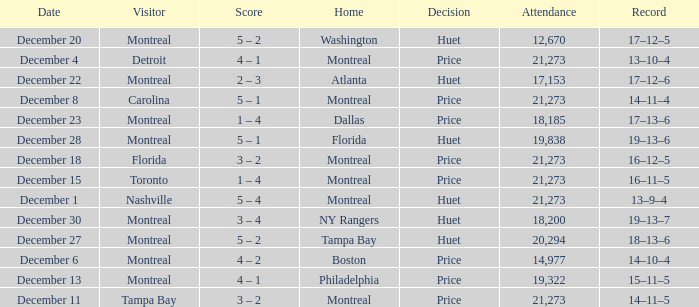What is the record on December 4? 13–10–4. 